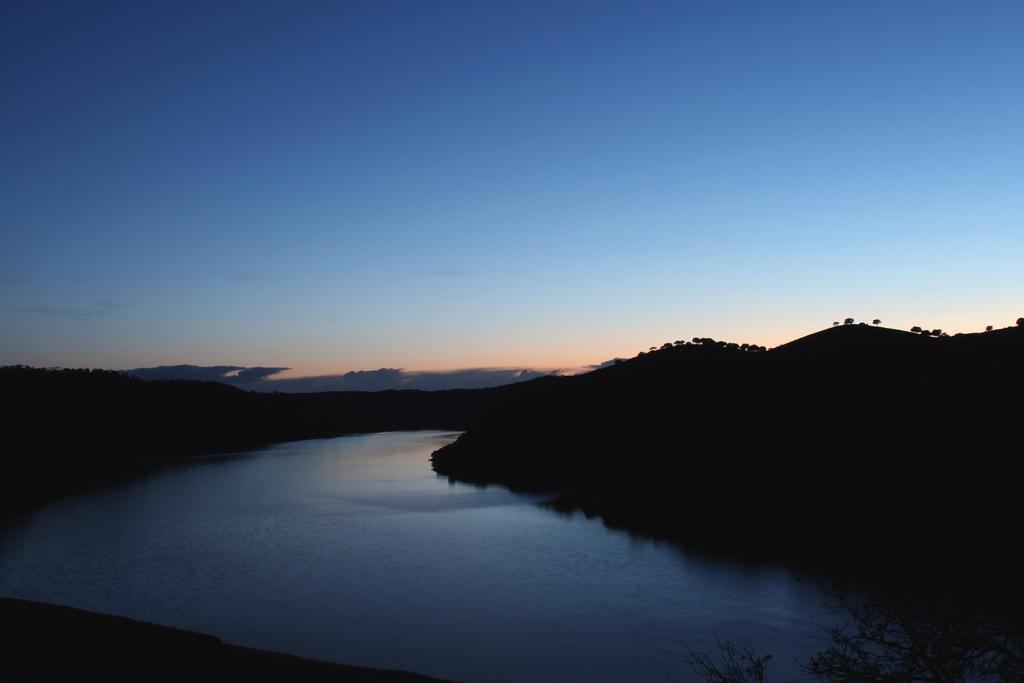What type of natural feature is at the bottom of the image? There is a river at the bottom of the image. What can be seen on the right side of the image? There are trees on the right side of the image. What is visible at the top of the image? The sky is visible at the top of the image. How many men are depicted in the image? There are no men present in the image; it features a river, trees, and the sky. What type of comfort can be found in the image? The image does not depict any specific type of comfort; it is a natural scene with a river, trees, and the sky. 